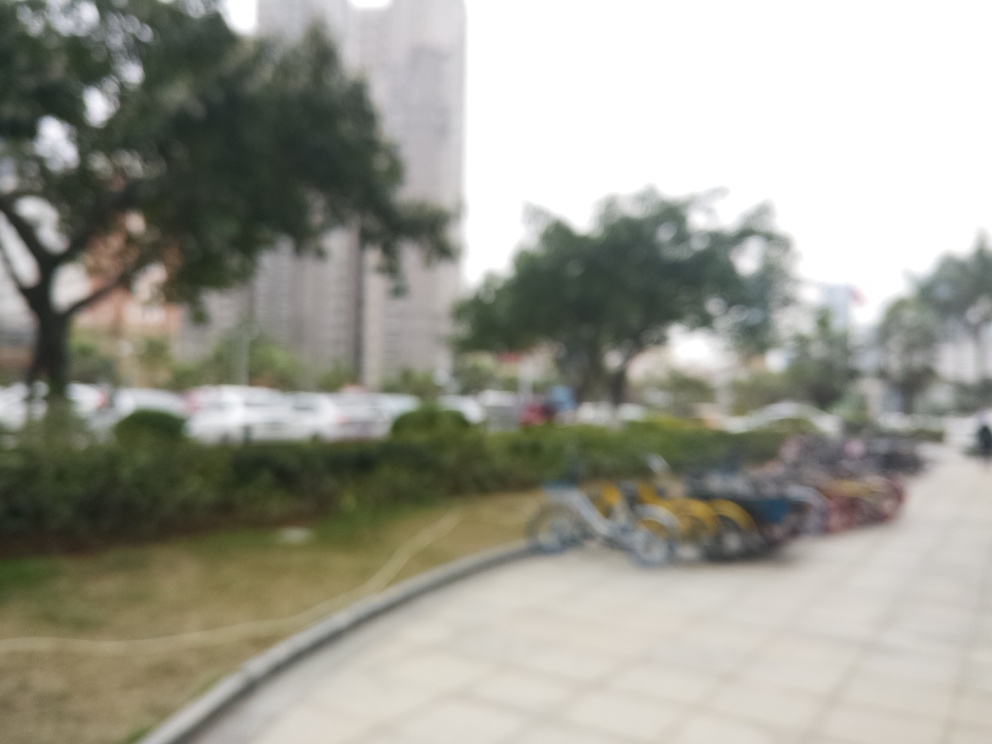How would you describe the quality of this image? A. Average B. Decent C. Very poor Answer with the option's letter from the given choices directly. Based on the visible assessment, the image is of low quality due to its blurred and unfocused characteristics. The details are indistinct and it is difficult to clearly identify the subjects within the image. Therefore, the most accurate description would be C. Very poor. 